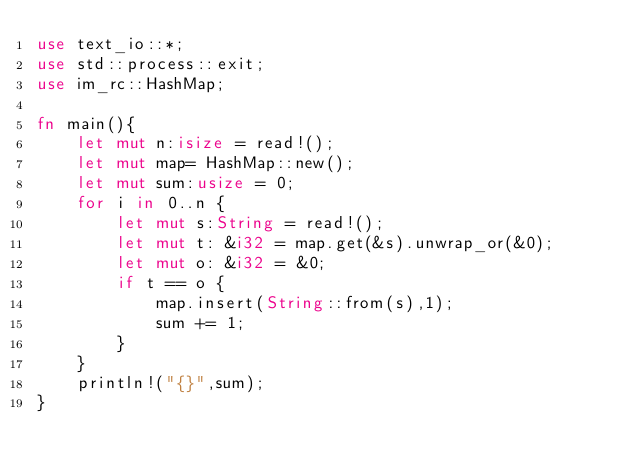<code> <loc_0><loc_0><loc_500><loc_500><_Rust_>use text_io::*;
use std::process::exit;
use im_rc::HashMap;

fn main(){
    let mut n:isize = read!();
    let mut map= HashMap::new();
    let mut sum:usize = 0;
    for i in 0..n {
        let mut s:String = read!();
        let mut t: &i32 = map.get(&s).unwrap_or(&0);
        let mut o: &i32 = &0;
        if t == o {
            map.insert(String::from(s),1);
            sum += 1;
        }
    }
    println!("{}",sum);
}</code> 